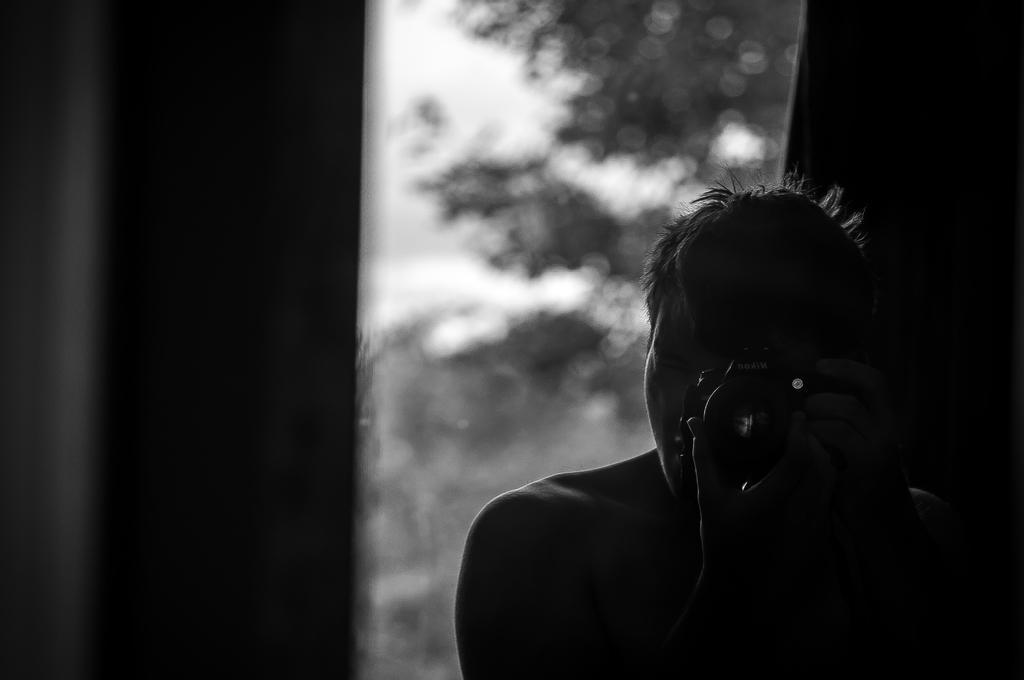Please provide a concise description of this image. In this image we can see a black and white picture. In the picture there are trees, sky, walls and a person holding a camera in his hands. 